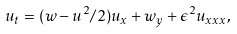<formula> <loc_0><loc_0><loc_500><loc_500>u _ { t } = ( w - u ^ { 2 } / 2 ) u _ { x } + w _ { y } + \epsilon ^ { 2 } u _ { x x x } ,</formula> 